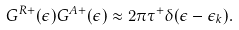<formula> <loc_0><loc_0><loc_500><loc_500>G ^ { R + } ( \epsilon ) G ^ { A + } ( \epsilon ) \approx 2 \pi \tau ^ { + } \delta ( \epsilon - \epsilon _ { k } ) .</formula> 